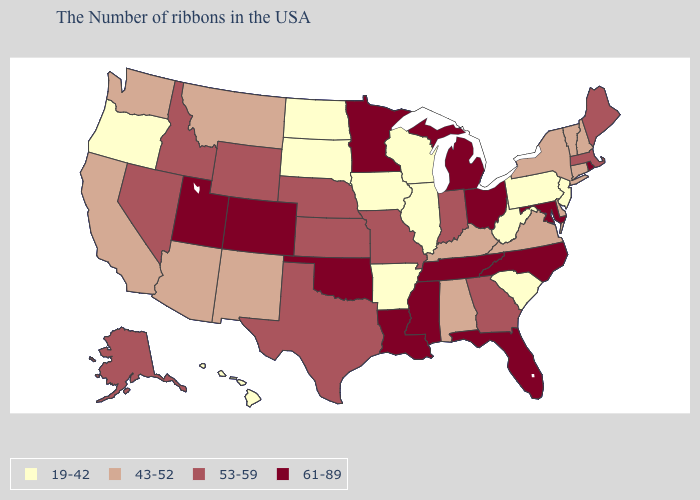Among the states that border Washington , does Oregon have the lowest value?
Concise answer only. Yes. Name the states that have a value in the range 43-52?
Be succinct. New Hampshire, Vermont, Connecticut, New York, Delaware, Virginia, Kentucky, Alabama, New Mexico, Montana, Arizona, California, Washington. What is the highest value in the USA?
Answer briefly. 61-89. What is the value of Montana?
Short answer required. 43-52. Does the first symbol in the legend represent the smallest category?
Answer briefly. Yes. Name the states that have a value in the range 53-59?
Give a very brief answer. Maine, Massachusetts, Georgia, Indiana, Missouri, Kansas, Nebraska, Texas, Wyoming, Idaho, Nevada, Alaska. Is the legend a continuous bar?
Concise answer only. No. Name the states that have a value in the range 19-42?
Write a very short answer. New Jersey, Pennsylvania, South Carolina, West Virginia, Wisconsin, Illinois, Arkansas, Iowa, South Dakota, North Dakota, Oregon, Hawaii. How many symbols are there in the legend?
Quick response, please. 4. What is the highest value in the South ?
Quick response, please. 61-89. Does the first symbol in the legend represent the smallest category?
Be succinct. Yes. Which states have the highest value in the USA?
Give a very brief answer. Rhode Island, Maryland, North Carolina, Ohio, Florida, Michigan, Tennessee, Mississippi, Louisiana, Minnesota, Oklahoma, Colorado, Utah. Which states have the lowest value in the South?
Answer briefly. South Carolina, West Virginia, Arkansas. What is the value of Idaho?
Answer briefly. 53-59. Does Pennsylvania have the lowest value in the Northeast?
Write a very short answer. Yes. 